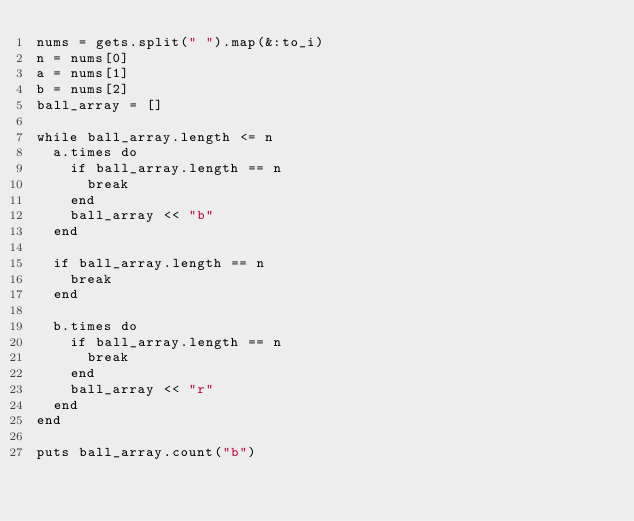<code> <loc_0><loc_0><loc_500><loc_500><_Ruby_>nums = gets.split(" ").map(&:to_i)
n = nums[0]
a = nums[1]
b = nums[2]
ball_array = []

while ball_array.length <= n
  a.times do
    if ball_array.length == n
      break
    end
    ball_array << "b"
  end
  
  if ball_array.length == n
    break
  end
  
  b.times do
    if ball_array.length == n
      break
    end
    ball_array << "r"
  end
end

puts ball_array.count("b")</code> 